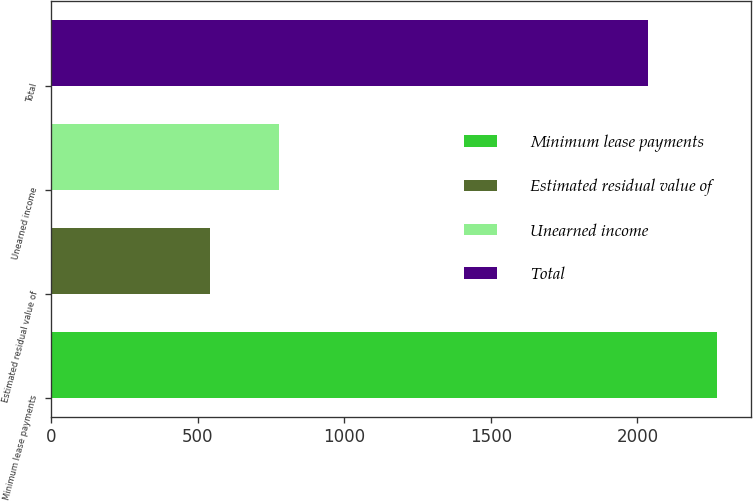Convert chart to OTSL. <chart><loc_0><loc_0><loc_500><loc_500><bar_chart><fcel>Minimum lease payments<fcel>Estimated residual value of<fcel>Unearned income<fcel>Total<nl><fcel>2272<fcel>541<fcel>776<fcel>2037<nl></chart> 